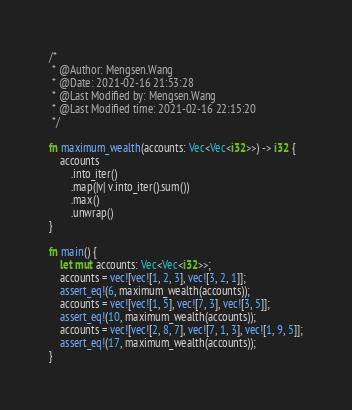<code> <loc_0><loc_0><loc_500><loc_500><_Rust_>/*
 * @Author: Mengsen.Wang
 * @Date: 2021-02-16 21:53:28
 * @Last Modified by: Mengsen.Wang
 * @Last Modified time: 2021-02-16 22:15:20
 */

fn maximum_wealth(accounts: Vec<Vec<i32>>) -> i32 {
    accounts
        .into_iter()
        .map(|v| v.into_iter().sum())
        .max()
        .unwrap()
}

fn main() {
    let mut accounts: Vec<Vec<i32>>;
    accounts = vec![vec![1, 2, 3], vec![3, 2, 1]];
    assert_eq!(6, maximum_wealth(accounts));
    accounts = vec![vec![1, 5], vec![7, 3], vec![3, 5]];
    assert_eq!(10, maximum_wealth(accounts));
    accounts = vec![vec![2, 8, 7], vec![7, 1, 3], vec![1, 9, 5]];
    assert_eq!(17, maximum_wealth(accounts));
}
</code> 